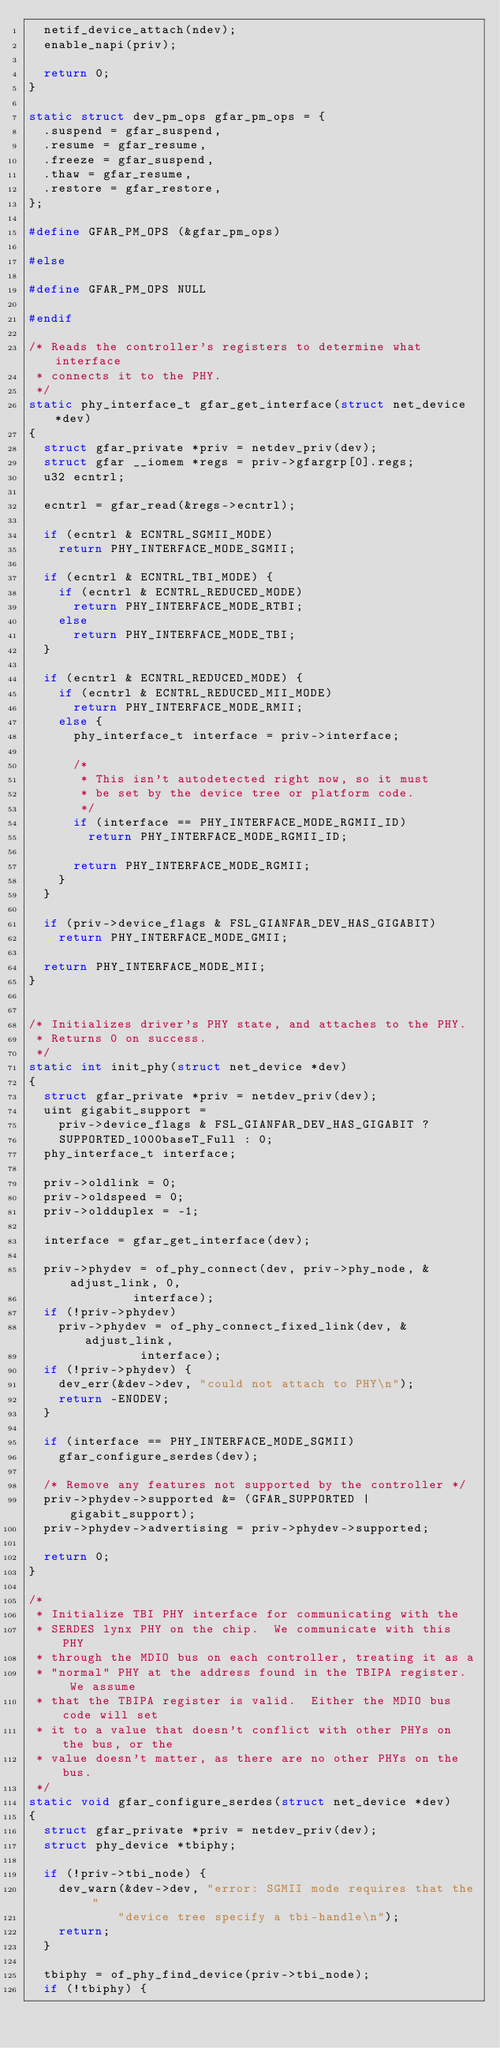Convert code to text. <code><loc_0><loc_0><loc_500><loc_500><_C_>	netif_device_attach(ndev);
	enable_napi(priv);

	return 0;
}

static struct dev_pm_ops gfar_pm_ops = {
	.suspend = gfar_suspend,
	.resume = gfar_resume,
	.freeze = gfar_suspend,
	.thaw = gfar_resume,
	.restore = gfar_restore,
};

#define GFAR_PM_OPS (&gfar_pm_ops)

#else

#define GFAR_PM_OPS NULL

#endif

/* Reads the controller's registers to determine what interface
 * connects it to the PHY.
 */
static phy_interface_t gfar_get_interface(struct net_device *dev)
{
	struct gfar_private *priv = netdev_priv(dev);
	struct gfar __iomem *regs = priv->gfargrp[0].regs;
	u32 ecntrl;

	ecntrl = gfar_read(&regs->ecntrl);

	if (ecntrl & ECNTRL_SGMII_MODE)
		return PHY_INTERFACE_MODE_SGMII;

	if (ecntrl & ECNTRL_TBI_MODE) {
		if (ecntrl & ECNTRL_REDUCED_MODE)
			return PHY_INTERFACE_MODE_RTBI;
		else
			return PHY_INTERFACE_MODE_TBI;
	}

	if (ecntrl & ECNTRL_REDUCED_MODE) {
		if (ecntrl & ECNTRL_REDUCED_MII_MODE)
			return PHY_INTERFACE_MODE_RMII;
		else {
			phy_interface_t interface = priv->interface;

			/*
			 * This isn't autodetected right now, so it must
			 * be set by the device tree or platform code.
			 */
			if (interface == PHY_INTERFACE_MODE_RGMII_ID)
				return PHY_INTERFACE_MODE_RGMII_ID;

			return PHY_INTERFACE_MODE_RGMII;
		}
	}

	if (priv->device_flags & FSL_GIANFAR_DEV_HAS_GIGABIT)
		return PHY_INTERFACE_MODE_GMII;

	return PHY_INTERFACE_MODE_MII;
}


/* Initializes driver's PHY state, and attaches to the PHY.
 * Returns 0 on success.
 */
static int init_phy(struct net_device *dev)
{
	struct gfar_private *priv = netdev_priv(dev);
	uint gigabit_support =
		priv->device_flags & FSL_GIANFAR_DEV_HAS_GIGABIT ?
		SUPPORTED_1000baseT_Full : 0;
	phy_interface_t interface;

	priv->oldlink = 0;
	priv->oldspeed = 0;
	priv->oldduplex = -1;

	interface = gfar_get_interface(dev);

	priv->phydev = of_phy_connect(dev, priv->phy_node, &adjust_link, 0,
				      interface);
	if (!priv->phydev)
		priv->phydev = of_phy_connect_fixed_link(dev, &adjust_link,
							 interface);
	if (!priv->phydev) {
		dev_err(&dev->dev, "could not attach to PHY\n");
		return -ENODEV;
	}

	if (interface == PHY_INTERFACE_MODE_SGMII)
		gfar_configure_serdes(dev);

	/* Remove any features not supported by the controller */
	priv->phydev->supported &= (GFAR_SUPPORTED | gigabit_support);
	priv->phydev->advertising = priv->phydev->supported;

	return 0;
}

/*
 * Initialize TBI PHY interface for communicating with the
 * SERDES lynx PHY on the chip.  We communicate with this PHY
 * through the MDIO bus on each controller, treating it as a
 * "normal" PHY at the address found in the TBIPA register.  We assume
 * that the TBIPA register is valid.  Either the MDIO bus code will set
 * it to a value that doesn't conflict with other PHYs on the bus, or the
 * value doesn't matter, as there are no other PHYs on the bus.
 */
static void gfar_configure_serdes(struct net_device *dev)
{
	struct gfar_private *priv = netdev_priv(dev);
	struct phy_device *tbiphy;

	if (!priv->tbi_node) {
		dev_warn(&dev->dev, "error: SGMII mode requires that the "
				    "device tree specify a tbi-handle\n");
		return;
	}

	tbiphy = of_phy_find_device(priv->tbi_node);
	if (!tbiphy) {</code> 